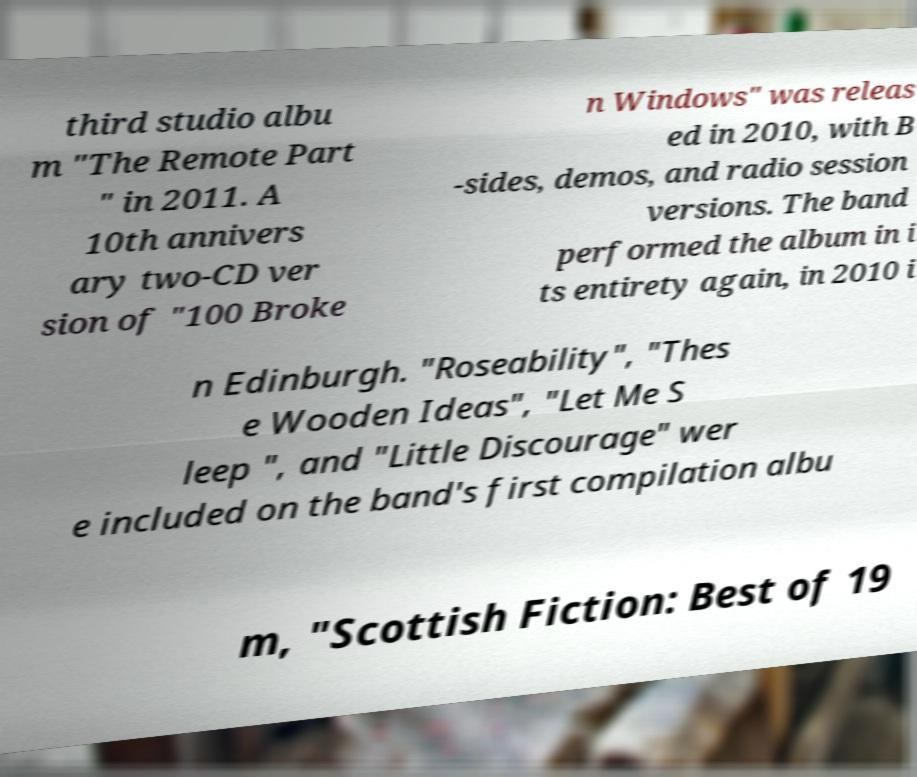Could you assist in decoding the text presented in this image and type it out clearly? third studio albu m "The Remote Part " in 2011. A 10th annivers ary two-CD ver sion of "100 Broke n Windows" was releas ed in 2010, with B -sides, demos, and radio session versions. The band performed the album in i ts entirety again, in 2010 i n Edinburgh. "Roseability", "Thes e Wooden Ideas", "Let Me S leep ", and "Little Discourage" wer e included on the band's first compilation albu m, "Scottish Fiction: Best of 19 